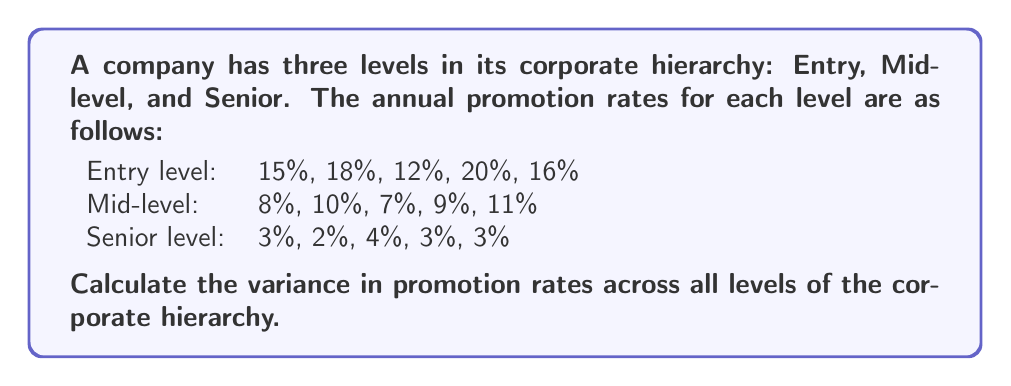Solve this math problem. To calculate the variance in promotion rates across all levels, we need to follow these steps:

1. Calculate the mean promotion rate for all levels combined:
   $$\bar{x} = \frac{\sum_{i=1}^{n} x_i}{n}$$
   where $x_i$ are the individual promotion rates and $n$ is the total number of rates.

   $$\bar{x} = \frac{15 + 18 + 12 + 20 + 16 + 8 + 10 + 7 + 9 + 11 + 3 + 2 + 4 + 3 + 3}{15} = 9.4\%$$

2. Calculate the squared differences from the mean for each promotion rate:
   $$(x_i - \bar{x})^2$$

3. Sum up all the squared differences:
   $$\sum_{i=1}^{n} (x_i - \bar{x})^2$$

4. Divide the sum by $(n-1)$ to get the variance:
   $$\text{Variance} = \frac{\sum_{i=1}^{n} (x_i - \bar{x})^2}{n-1}$$

Let's calculate the squared differences:
$$(15 - 9.4)^2 = 31.36$$
$$(18 - 9.4)^2 = 73.96$$
$$(12 - 9.4)^2 = 6.76$$
$$(20 - 9.4)^2 = 112.36$$
$$(16 - 9.4)^2 = 43.56$$
$$(8 - 9.4)^2 = 1.96$$
$$(10 - 9.4)^2 = 0.36$$
$$(7 - 9.4)^2 = 5.76$$
$$(9 - 9.4)^2 = 0.16$$
$$(11 - 9.4)^2 = 2.56$$
$$(3 - 9.4)^2 = 40.96$$
$$(2 - 9.4)^2 = 54.76$$
$$(4 - 9.4)^2 = 29.16$$
$$(3 - 9.4)^2 = 40.96$$
$$(3 - 9.4)^2 = 40.96$$

Sum of squared differences: 485.64

Now, we can calculate the variance:

$$\text{Variance} = \frac{485.64}{15-1} = 34.69$$
Answer: The variance in promotion rates across all levels of the corporate hierarchy is 34.69 (percentage points squared). 